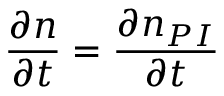Convert formula to latex. <formula><loc_0><loc_0><loc_500><loc_500>\frac { \partial n } { \partial t } = \frac { \partial n _ { P I } } { \partial t }</formula> 